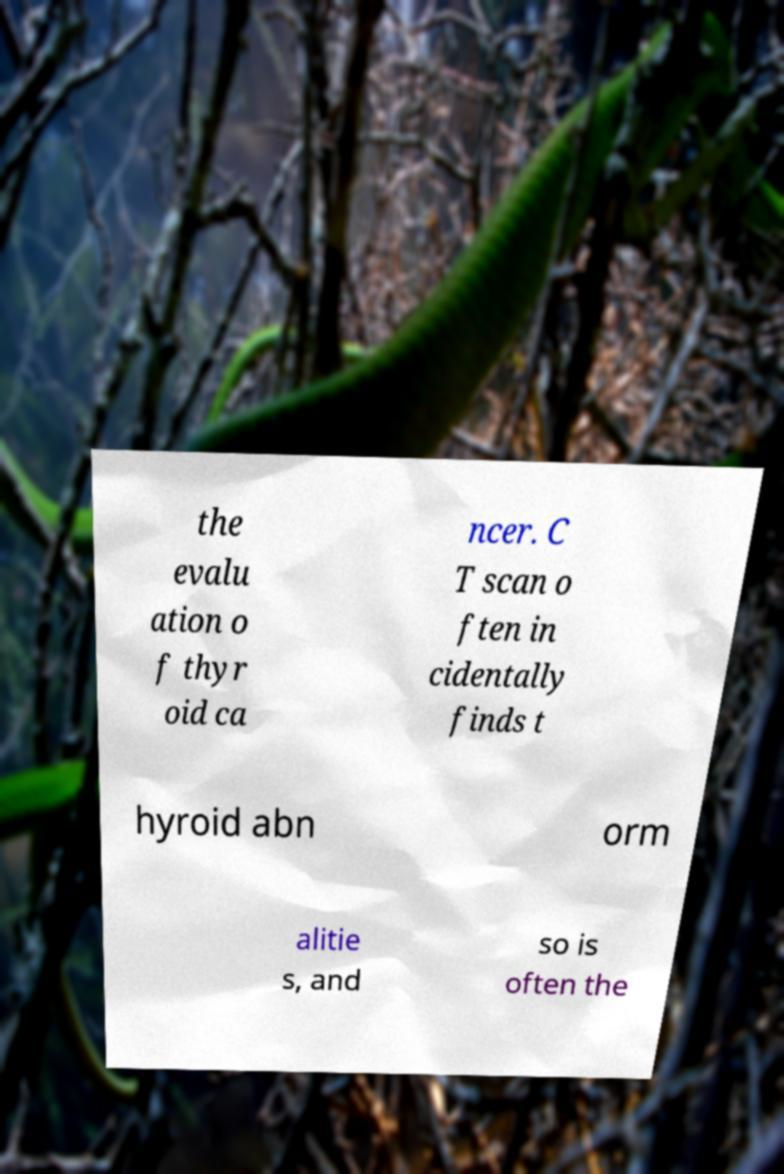There's text embedded in this image that I need extracted. Can you transcribe it verbatim? the evalu ation o f thyr oid ca ncer. C T scan o ften in cidentally finds t hyroid abn orm alitie s, and so is often the 